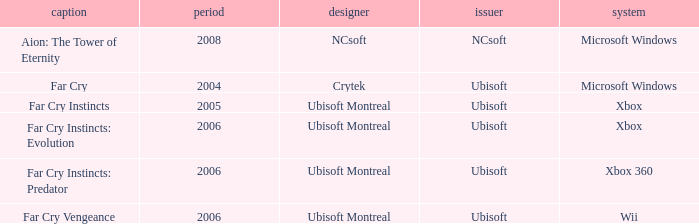Which title has a year prior to 2008 and xbox 360 as the platform? Far Cry Instincts: Predator. 